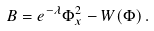<formula> <loc_0><loc_0><loc_500><loc_500>B = e ^ { - \lambda } \Phi _ { x } ^ { 2 } - W ( \Phi ) \, .</formula> 